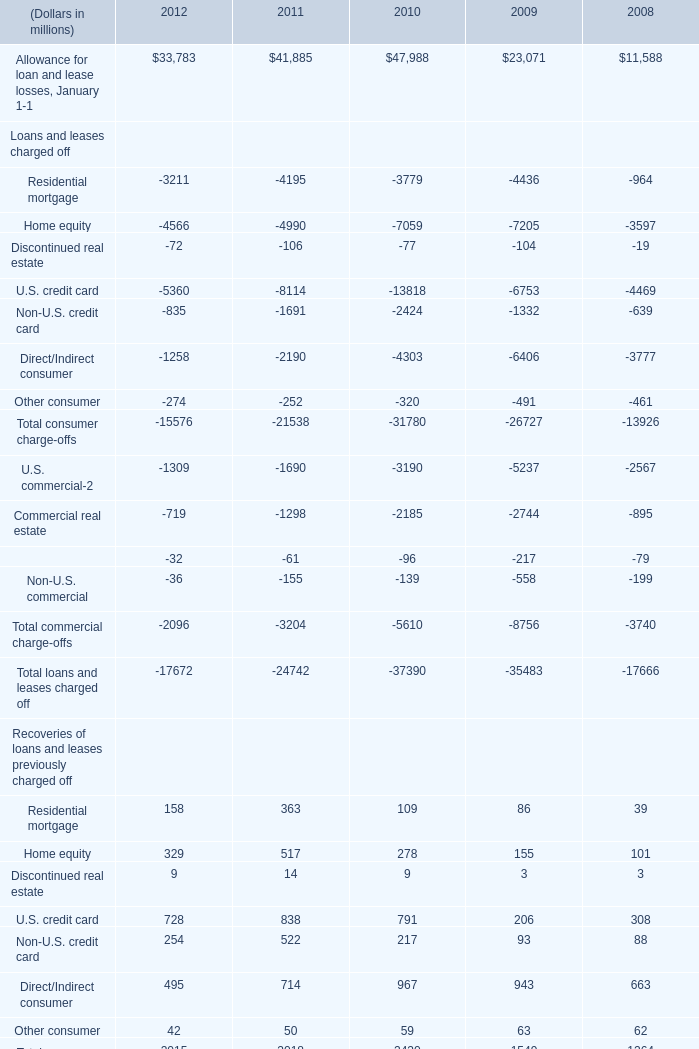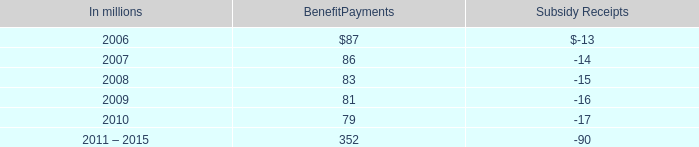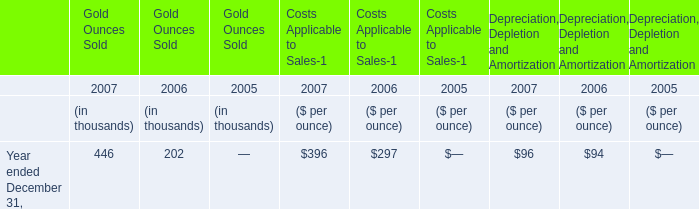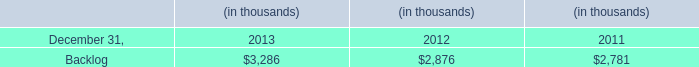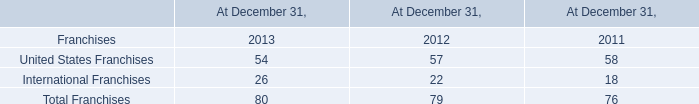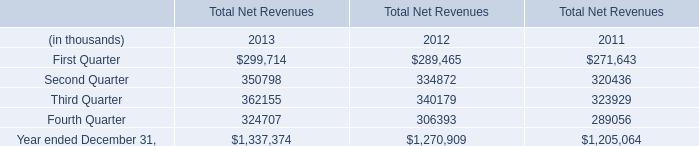What's the current growth rate of commercial lease financing in terms of recoveries of loans and leases previously charged off? 
Computations: ((38 - 37) / 37)
Answer: 0.02703. 